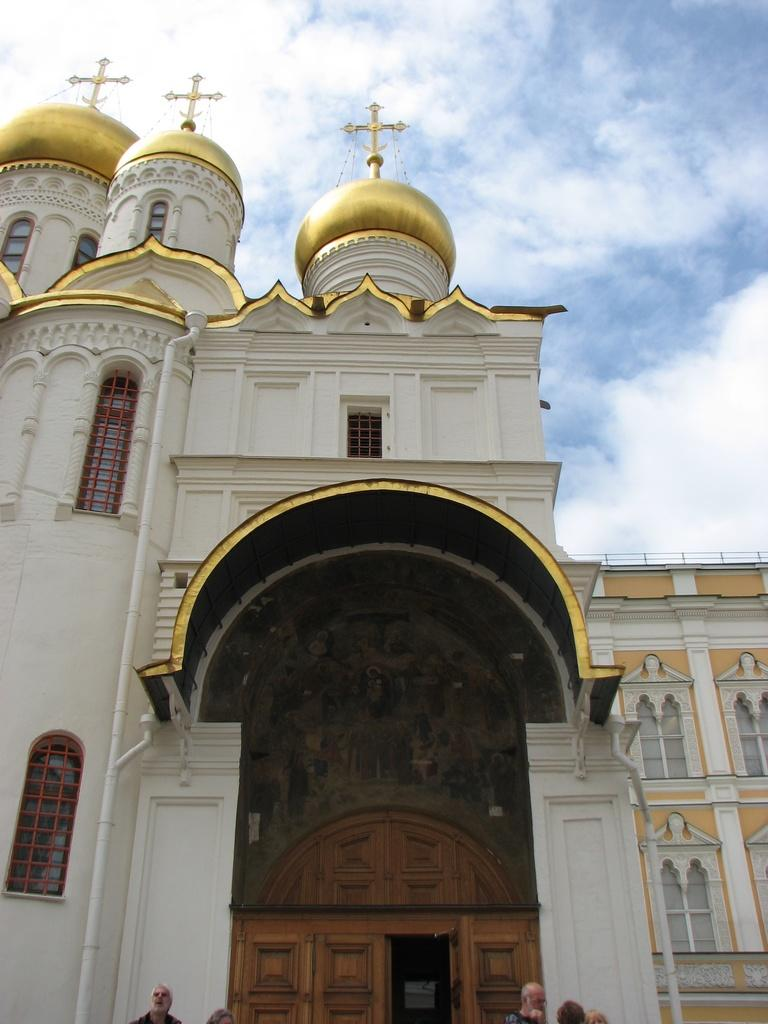What type of structure is visible in the image? There is a building with windows in the image. Are there any people near the building? Yes, there are people in front of the building. What can be seen in the background of the image? The sky is visible in the background of the image. What is the condition of the sky in the image? Clouds are present in the sky. Can you see any boats or vessels in the image? No, there are no boats or vessels present in the image. How many people are biting the building in the image? There are no people biting the building in the image; it is not possible for people to bite a building. 